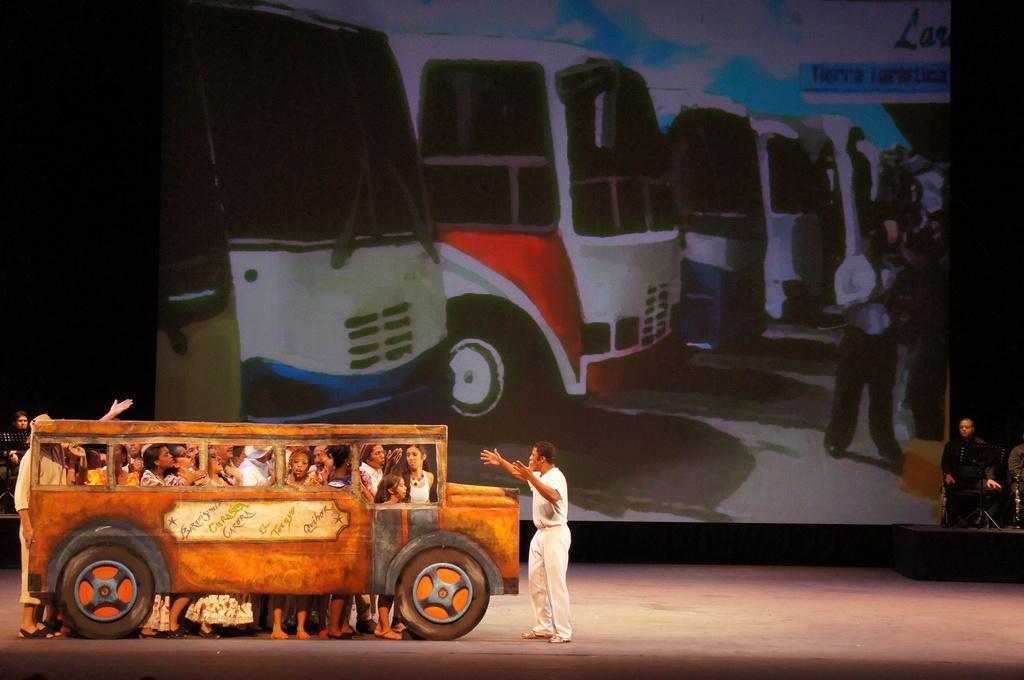In one or two sentences, can you explain what this image depicts? In this picture there are group of people standing behind the artificial bus and there is a man with white dress is standing. On the right side of the image there are two people sitting and there are objects. On the left side of the image there is a person sitting and there is an object. At the back there is a screen. On the screen there are pictures of abuses and there are group of people and there is a board and there is text on the board. At the top there is sky and there are clouds. At the bottom there is a road. 